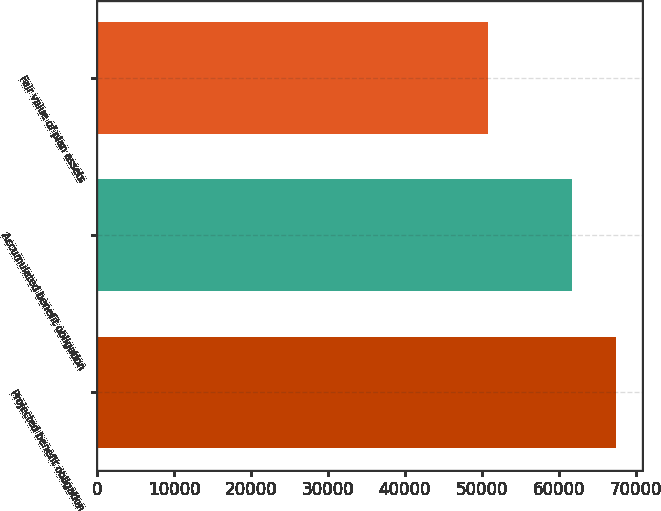Convert chart to OTSL. <chart><loc_0><loc_0><loc_500><loc_500><bar_chart><fcel>Projected benefit obligation<fcel>Accumulated benefit obligation<fcel>Fair value of plan assets<nl><fcel>67418<fcel>61675<fcel>50820<nl></chart> 